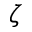Convert formula to latex. <formula><loc_0><loc_0><loc_500><loc_500>\zeta</formula> 